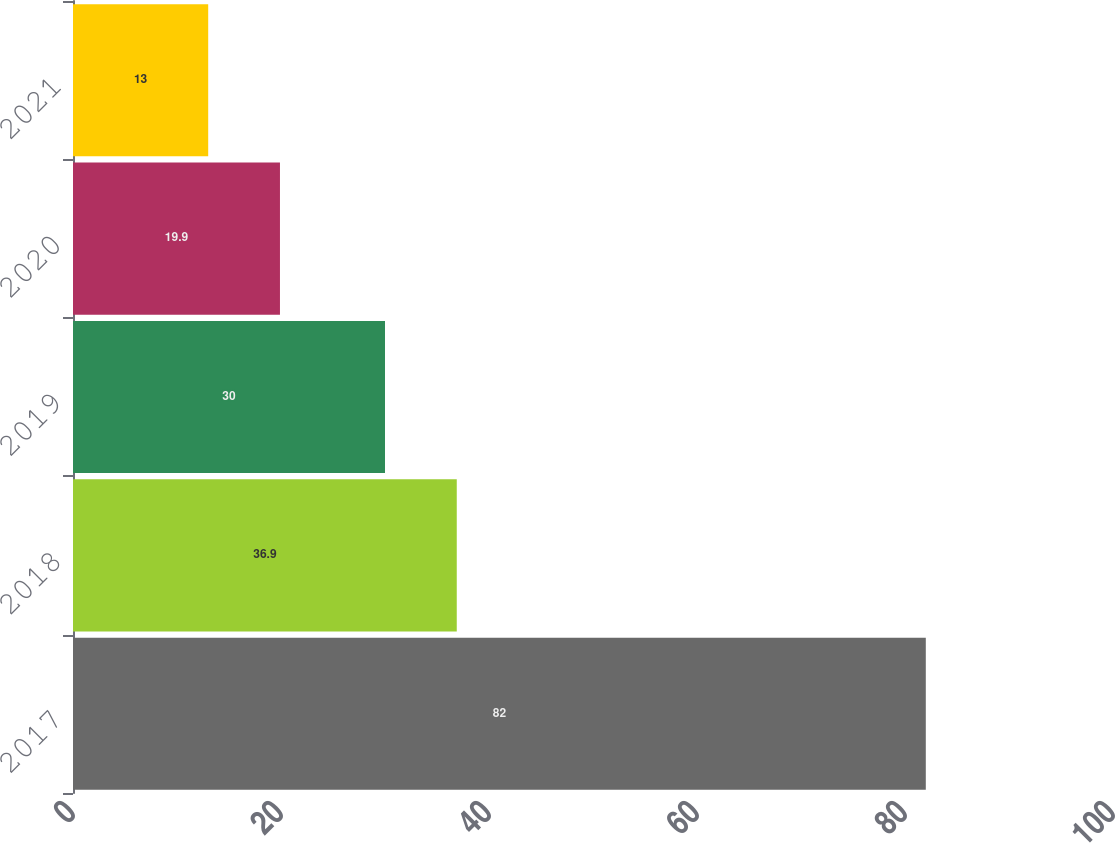Convert chart to OTSL. <chart><loc_0><loc_0><loc_500><loc_500><bar_chart><fcel>2017<fcel>2018<fcel>2019<fcel>2020<fcel>2021<nl><fcel>82<fcel>36.9<fcel>30<fcel>19.9<fcel>13<nl></chart> 